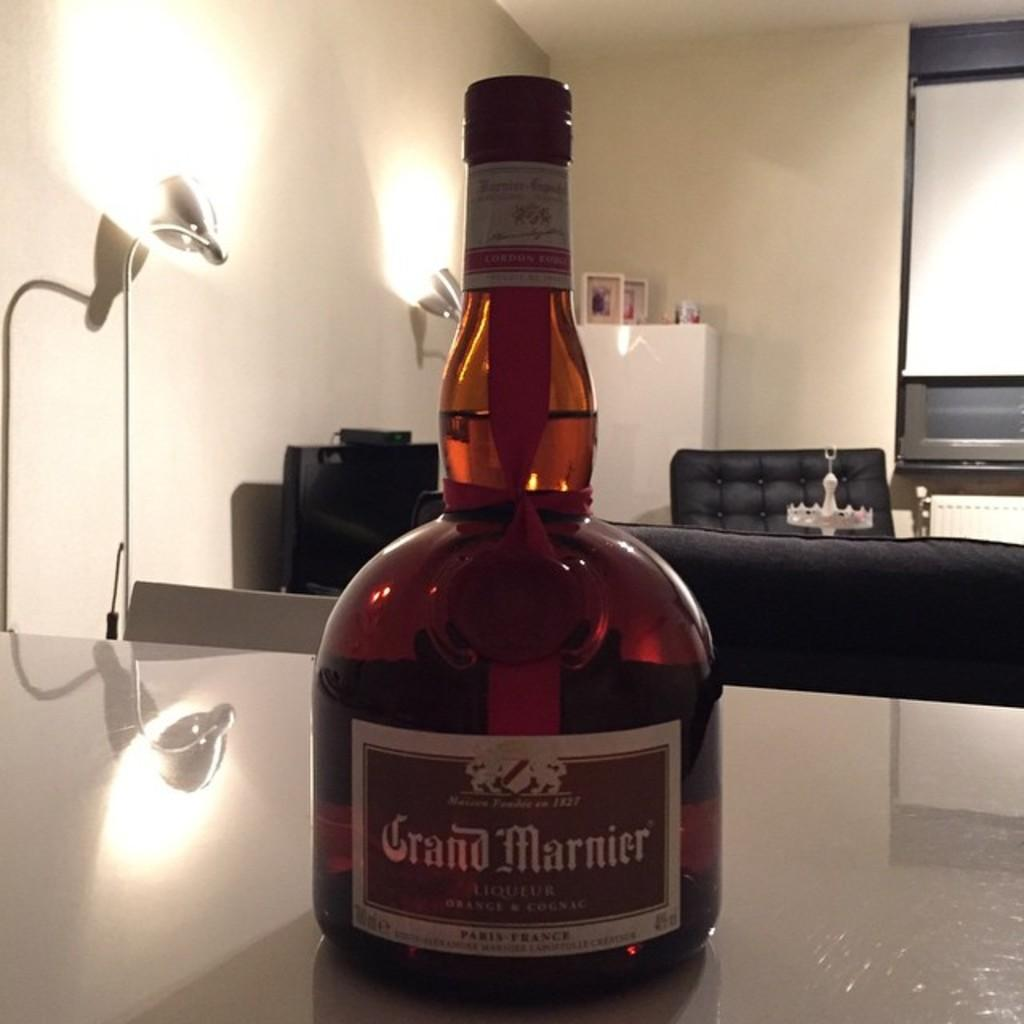What can be seen on the table in the image? There is a beer bottle on a table in the image. What can be seen in the background of the image? There are lights, a cupboard, a chair, another table, and a screen in the background of the image. What is inside the cupboard in the background of the image? There are photo frames in the cupboard in the background of the image. How many pets are visible in the image? There are no pets visible in the image. What day of the week is it in the image? The day of the week is not mentioned or visible in the image. 